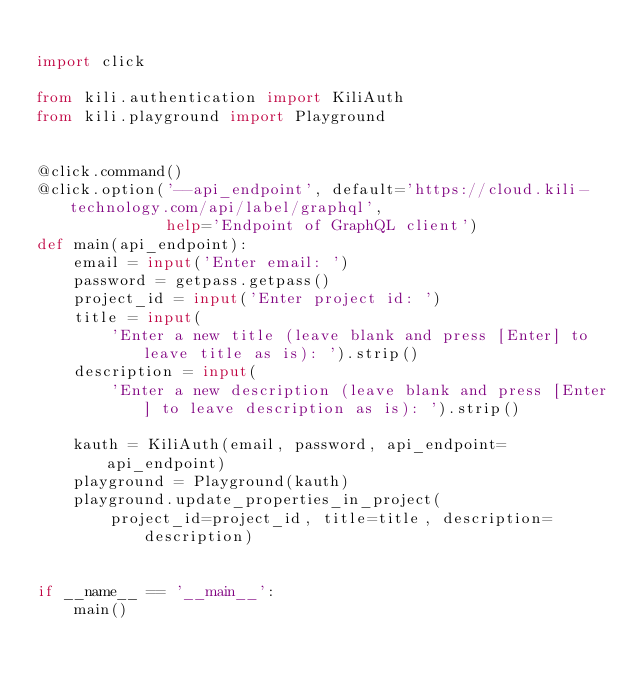<code> <loc_0><loc_0><loc_500><loc_500><_Python_>
import click

from kili.authentication import KiliAuth
from kili.playground import Playground


@click.command()
@click.option('--api_endpoint', default='https://cloud.kili-technology.com/api/label/graphql',
              help='Endpoint of GraphQL client')
def main(api_endpoint):
    email = input('Enter email: ')
    password = getpass.getpass()
    project_id = input('Enter project id: ')
    title = input(
        'Enter a new title (leave blank and press [Enter] to leave title as is): ').strip()
    description = input(
        'Enter a new description (leave blank and press [Enter] to leave description as is): ').strip()

    kauth = KiliAuth(email, password, api_endpoint=api_endpoint)
    playground = Playground(kauth)
    playground.update_properties_in_project(
        project_id=project_id, title=title, description=description)


if __name__ == '__main__':
    main()
</code> 